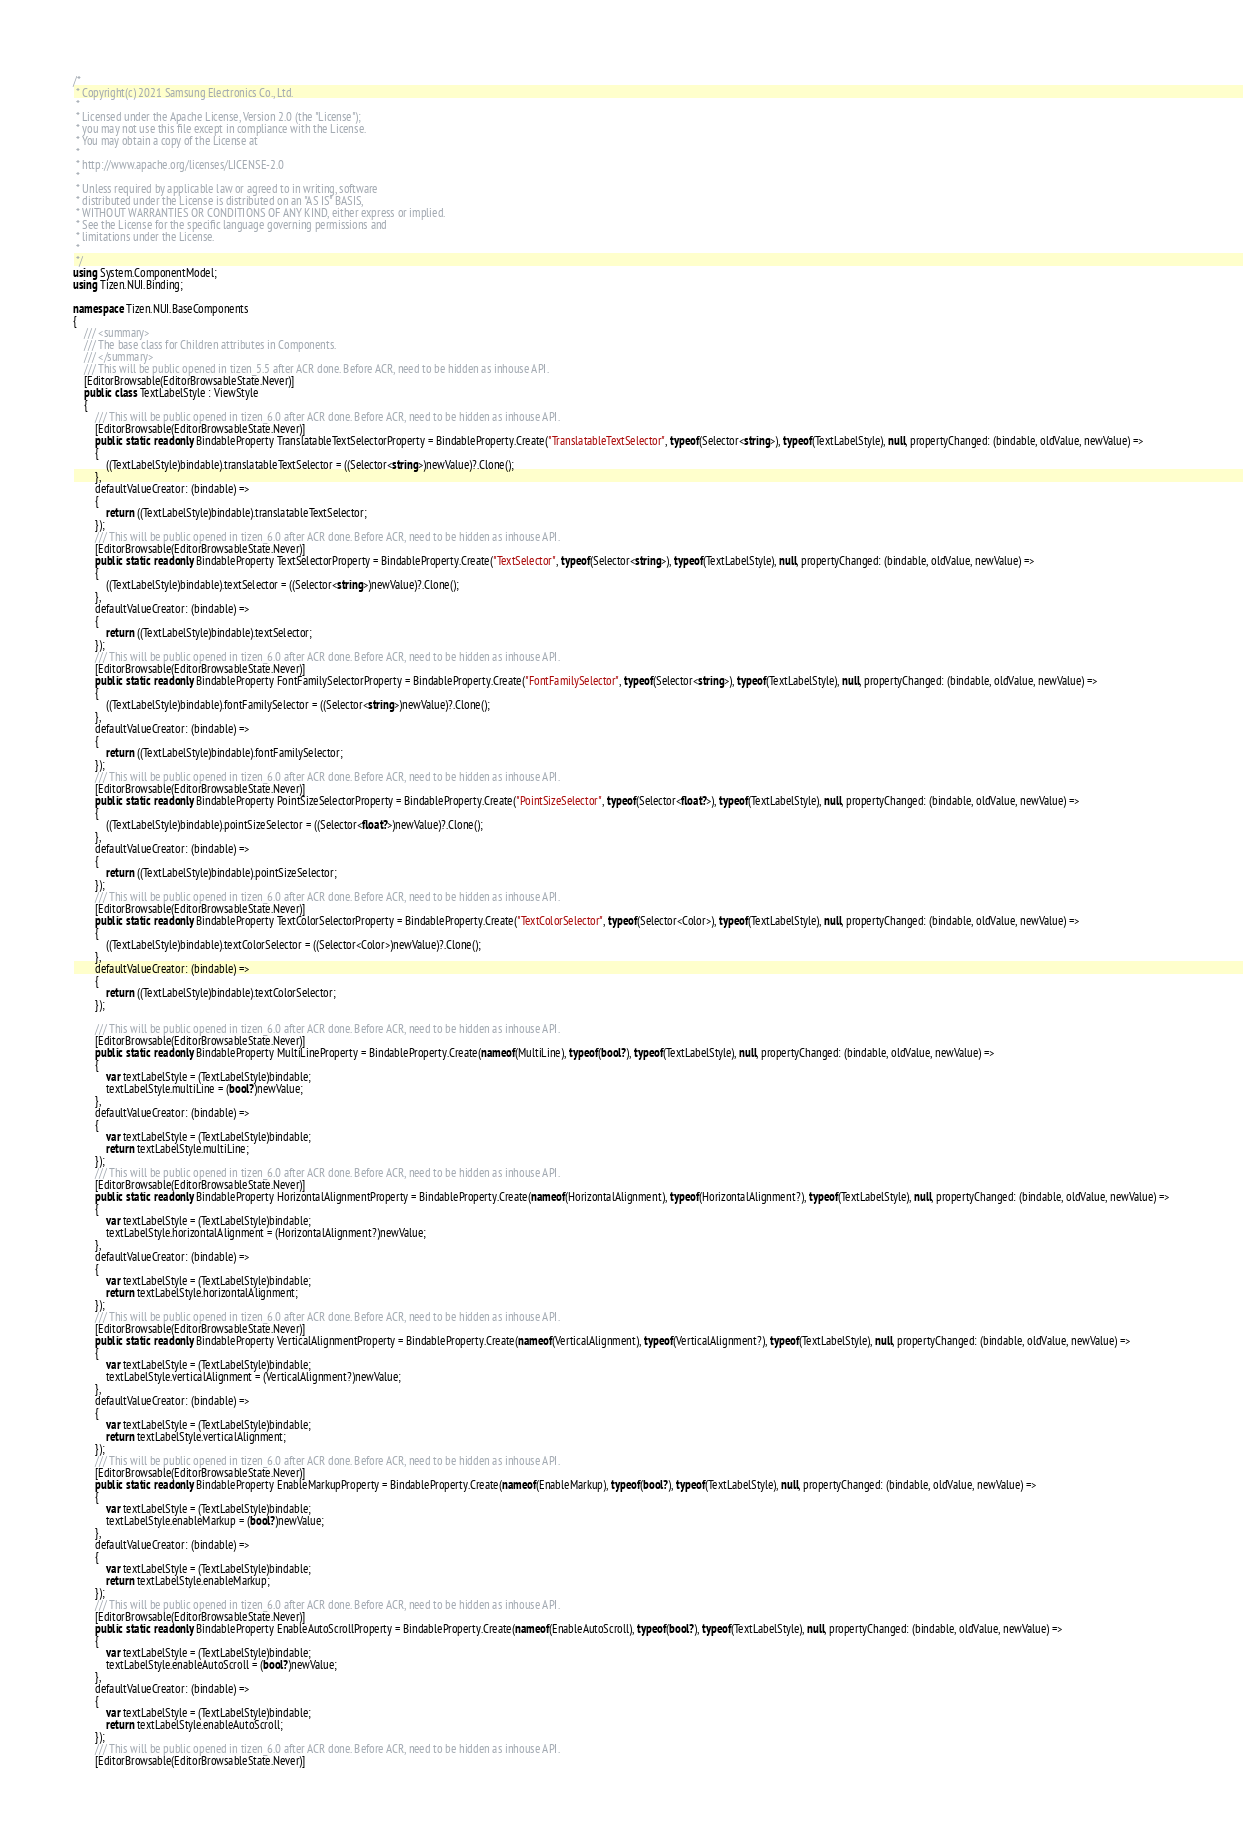Convert code to text. <code><loc_0><loc_0><loc_500><loc_500><_C#_>/*
 * Copyright(c) 2021 Samsung Electronics Co., Ltd.
 *
 * Licensed under the Apache License, Version 2.0 (the "License");
 * you may not use this file except in compliance with the License.
 * You may obtain a copy of the License at
 *
 * http://www.apache.org/licenses/LICENSE-2.0
 *
 * Unless required by applicable law or agreed to in writing, software
 * distributed under the License is distributed on an "AS IS" BASIS,
 * WITHOUT WARRANTIES OR CONDITIONS OF ANY KIND, either express or implied.
 * See the License for the specific language governing permissions and
 * limitations under the License.
 *
 */
using System.ComponentModel;
using Tizen.NUI.Binding;

namespace Tizen.NUI.BaseComponents
{
    /// <summary>
    /// The base class for Children attributes in Components.
    /// </summary>
    /// This will be public opened in tizen_5.5 after ACR done. Before ACR, need to be hidden as inhouse API.
    [EditorBrowsable(EditorBrowsableState.Never)]
    public class TextLabelStyle : ViewStyle
    {
        /// This will be public opened in tizen_6.0 after ACR done. Before ACR, need to be hidden as inhouse API.
        [EditorBrowsable(EditorBrowsableState.Never)]
        public static readonly BindableProperty TranslatableTextSelectorProperty = BindableProperty.Create("TranslatableTextSelector", typeof(Selector<string>), typeof(TextLabelStyle), null, propertyChanged: (bindable, oldValue, newValue) =>
        {
            ((TextLabelStyle)bindable).translatableTextSelector = ((Selector<string>)newValue)?.Clone();
        },
        defaultValueCreator: (bindable) =>
        {
            return ((TextLabelStyle)bindable).translatableTextSelector;
        });
        /// This will be public opened in tizen_6.0 after ACR done. Before ACR, need to be hidden as inhouse API.
        [EditorBrowsable(EditorBrowsableState.Never)]
        public static readonly BindableProperty TextSelectorProperty = BindableProperty.Create("TextSelector", typeof(Selector<string>), typeof(TextLabelStyle), null, propertyChanged: (bindable, oldValue, newValue) =>
        {
            ((TextLabelStyle)bindable).textSelector = ((Selector<string>)newValue)?.Clone();
        },
        defaultValueCreator: (bindable) =>
        {
            return ((TextLabelStyle)bindable).textSelector;
        });
        /// This will be public opened in tizen_6.0 after ACR done. Before ACR, need to be hidden as inhouse API.
        [EditorBrowsable(EditorBrowsableState.Never)]
        public static readonly BindableProperty FontFamilySelectorProperty = BindableProperty.Create("FontFamilySelector", typeof(Selector<string>), typeof(TextLabelStyle), null, propertyChanged: (bindable, oldValue, newValue) =>
        {
            ((TextLabelStyle)bindable).fontFamilySelector = ((Selector<string>)newValue)?.Clone();
        },
        defaultValueCreator: (bindable) =>
        {
            return ((TextLabelStyle)bindable).fontFamilySelector;
        });
        /// This will be public opened in tizen_6.0 after ACR done. Before ACR, need to be hidden as inhouse API.
        [EditorBrowsable(EditorBrowsableState.Never)]
        public static readonly BindableProperty PointSizeSelectorProperty = BindableProperty.Create("PointSizeSelector", typeof(Selector<float?>), typeof(TextLabelStyle), null, propertyChanged: (bindable, oldValue, newValue) =>
        {
            ((TextLabelStyle)bindable).pointSizeSelector = ((Selector<float?>)newValue)?.Clone();
        },
        defaultValueCreator: (bindable) =>
        {
            return ((TextLabelStyle)bindable).pointSizeSelector;
        });
        /// This will be public opened in tizen_6.0 after ACR done. Before ACR, need to be hidden as inhouse API.
        [EditorBrowsable(EditorBrowsableState.Never)]
        public static readonly BindableProperty TextColorSelectorProperty = BindableProperty.Create("TextColorSelector", typeof(Selector<Color>), typeof(TextLabelStyle), null, propertyChanged: (bindable, oldValue, newValue) =>
        {
            ((TextLabelStyle)bindable).textColorSelector = ((Selector<Color>)newValue)?.Clone();
        },
        defaultValueCreator: (bindable) =>
        {
            return ((TextLabelStyle)bindable).textColorSelector;
        });

        /// This will be public opened in tizen_6.0 after ACR done. Before ACR, need to be hidden as inhouse API.
        [EditorBrowsable(EditorBrowsableState.Never)]
        public static readonly BindableProperty MultiLineProperty = BindableProperty.Create(nameof(MultiLine), typeof(bool?), typeof(TextLabelStyle), null, propertyChanged: (bindable, oldValue, newValue) =>
        {
            var textLabelStyle = (TextLabelStyle)bindable;
            textLabelStyle.multiLine = (bool?)newValue;
        },
        defaultValueCreator: (bindable) =>
        {
            var textLabelStyle = (TextLabelStyle)bindable;
            return textLabelStyle.multiLine;
        });
        /// This will be public opened in tizen_6.0 after ACR done. Before ACR, need to be hidden as inhouse API.
        [EditorBrowsable(EditorBrowsableState.Never)]
        public static readonly BindableProperty HorizontalAlignmentProperty = BindableProperty.Create(nameof(HorizontalAlignment), typeof(HorizontalAlignment?), typeof(TextLabelStyle), null, propertyChanged: (bindable, oldValue, newValue) =>
        {
            var textLabelStyle = (TextLabelStyle)bindable;
            textLabelStyle.horizontalAlignment = (HorizontalAlignment?)newValue;
        },
        defaultValueCreator: (bindable) =>
        {
            var textLabelStyle = (TextLabelStyle)bindable;
            return textLabelStyle.horizontalAlignment;
        });
        /// This will be public opened in tizen_6.0 after ACR done. Before ACR, need to be hidden as inhouse API.
        [EditorBrowsable(EditorBrowsableState.Never)]
        public static readonly BindableProperty VerticalAlignmentProperty = BindableProperty.Create(nameof(VerticalAlignment), typeof(VerticalAlignment?), typeof(TextLabelStyle), null, propertyChanged: (bindable, oldValue, newValue) =>
        {
            var textLabelStyle = (TextLabelStyle)bindable;
            textLabelStyle.verticalAlignment = (VerticalAlignment?)newValue;
        },
        defaultValueCreator: (bindable) =>
        {
            var textLabelStyle = (TextLabelStyle)bindable;
            return textLabelStyle.verticalAlignment;
        });
        /// This will be public opened in tizen_6.0 after ACR done. Before ACR, need to be hidden as inhouse API.
        [EditorBrowsable(EditorBrowsableState.Never)]
        public static readonly BindableProperty EnableMarkupProperty = BindableProperty.Create(nameof(EnableMarkup), typeof(bool?), typeof(TextLabelStyle), null, propertyChanged: (bindable, oldValue, newValue) =>
        {
            var textLabelStyle = (TextLabelStyle)bindable;
            textLabelStyle.enableMarkup = (bool?)newValue;
        },
        defaultValueCreator: (bindable) =>
        {
            var textLabelStyle = (TextLabelStyle)bindable;
            return textLabelStyle.enableMarkup;
        });
        /// This will be public opened in tizen_6.0 after ACR done. Before ACR, need to be hidden as inhouse API.
        [EditorBrowsable(EditorBrowsableState.Never)]
        public static readonly BindableProperty EnableAutoScrollProperty = BindableProperty.Create(nameof(EnableAutoScroll), typeof(bool?), typeof(TextLabelStyle), null, propertyChanged: (bindable, oldValue, newValue) =>
        {
            var textLabelStyle = (TextLabelStyle)bindable;
            textLabelStyle.enableAutoScroll = (bool?)newValue;
        },
        defaultValueCreator: (bindable) =>
        {
            var textLabelStyle = (TextLabelStyle)bindable;
            return textLabelStyle.enableAutoScroll;
        });
        /// This will be public opened in tizen_6.0 after ACR done. Before ACR, need to be hidden as inhouse API.
        [EditorBrowsable(EditorBrowsableState.Never)]</code> 